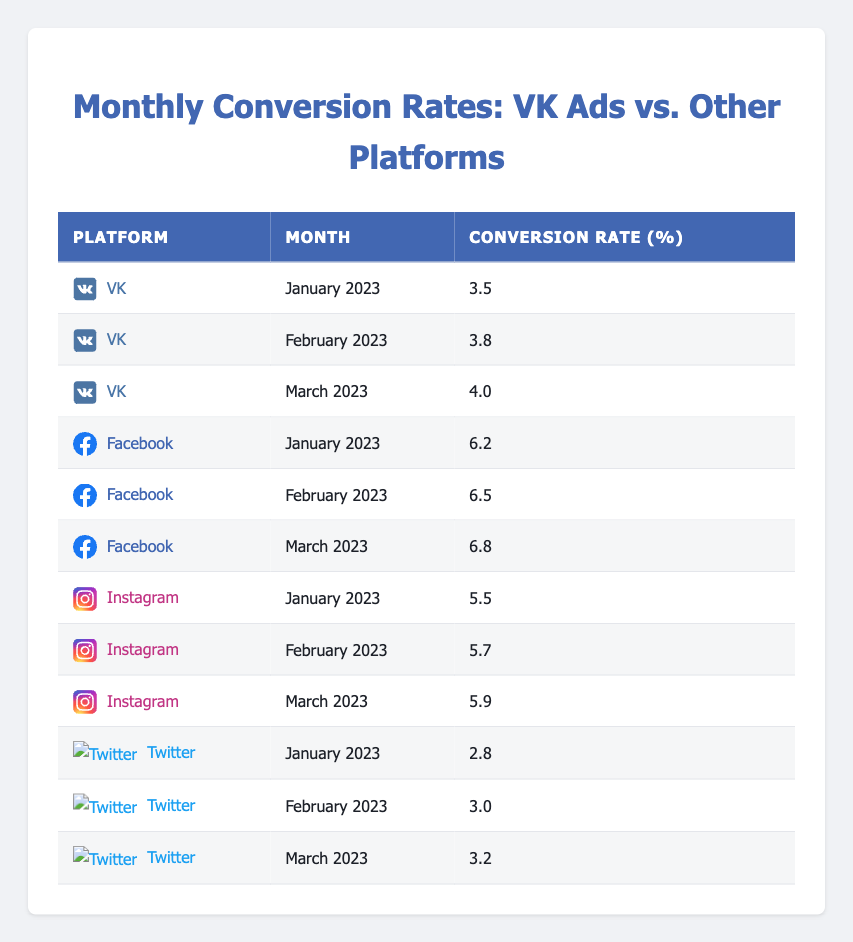What is the conversion rate for VK in February 2023? The table indicates that the conversion rate for VK in February 2023 is listed directly in the row for VK and February 2023, which shows 3.8%.
Answer: 3.8 Which platform had the highest conversion rate in January 2023? By comparing the conversion rates for all platforms in January 2023, we see that Facebook has the highest conversion rate of 6.2%, while VK, Instagram, and Twitter have lower rates.
Answer: Facebook What is the difference in conversion rates between Instagram and Twitter in March 2023? In March 2023, Instagram's conversion rate is 5.9%, and Twitter's is 3.2%. The difference is calculated by subtracting Twitter's rate from Instagram's: 5.9% - 3.2% = 2.7%.
Answer: 2.7 Is the conversion rate for VK in March 2023 greater than that for Twitter in the same month? In March 2023, VK's conversion rate is 4.0%, while Twitter's is 3.2%. Therefore, VK's rate is indeed higher than Twitter's.
Answer: Yes What is the average conversion rate for Facebook from January to March 2023? To find the average conversion rate for Facebook, we sum the conversion rates for January (6.2%), February (6.5%), and March (6.8%): 6.2% + 6.5% + 6.8% = 19.5%. Dividing by the number of months (3) gives us an average of 19.5% / 3 = 6.5%.
Answer: 6.5 Which platform had the lowest conversion rate across the three months? Looking through the data across all three months, we see that Twitter consistently has the lowest conversion rates: 2.8% in January, 3.0% in February, and 3.2% in March, making it the platform with the lowest rates overall.
Answer: Twitter Was there a month where VK's conversion rate exceeded 4%? Checking the conversion rates for VK, we see that it reached 4.0% in March 2023, which is equal to 4%, but it did not exceed it in the earlier months.
Answer: No What was the trend for VK's conversion rates over the three months? By examining VK's conversion rates over January (3.5%), February (3.8%), and March (4.0%), we notice a consistent increase month over month.
Answer: Increasing 